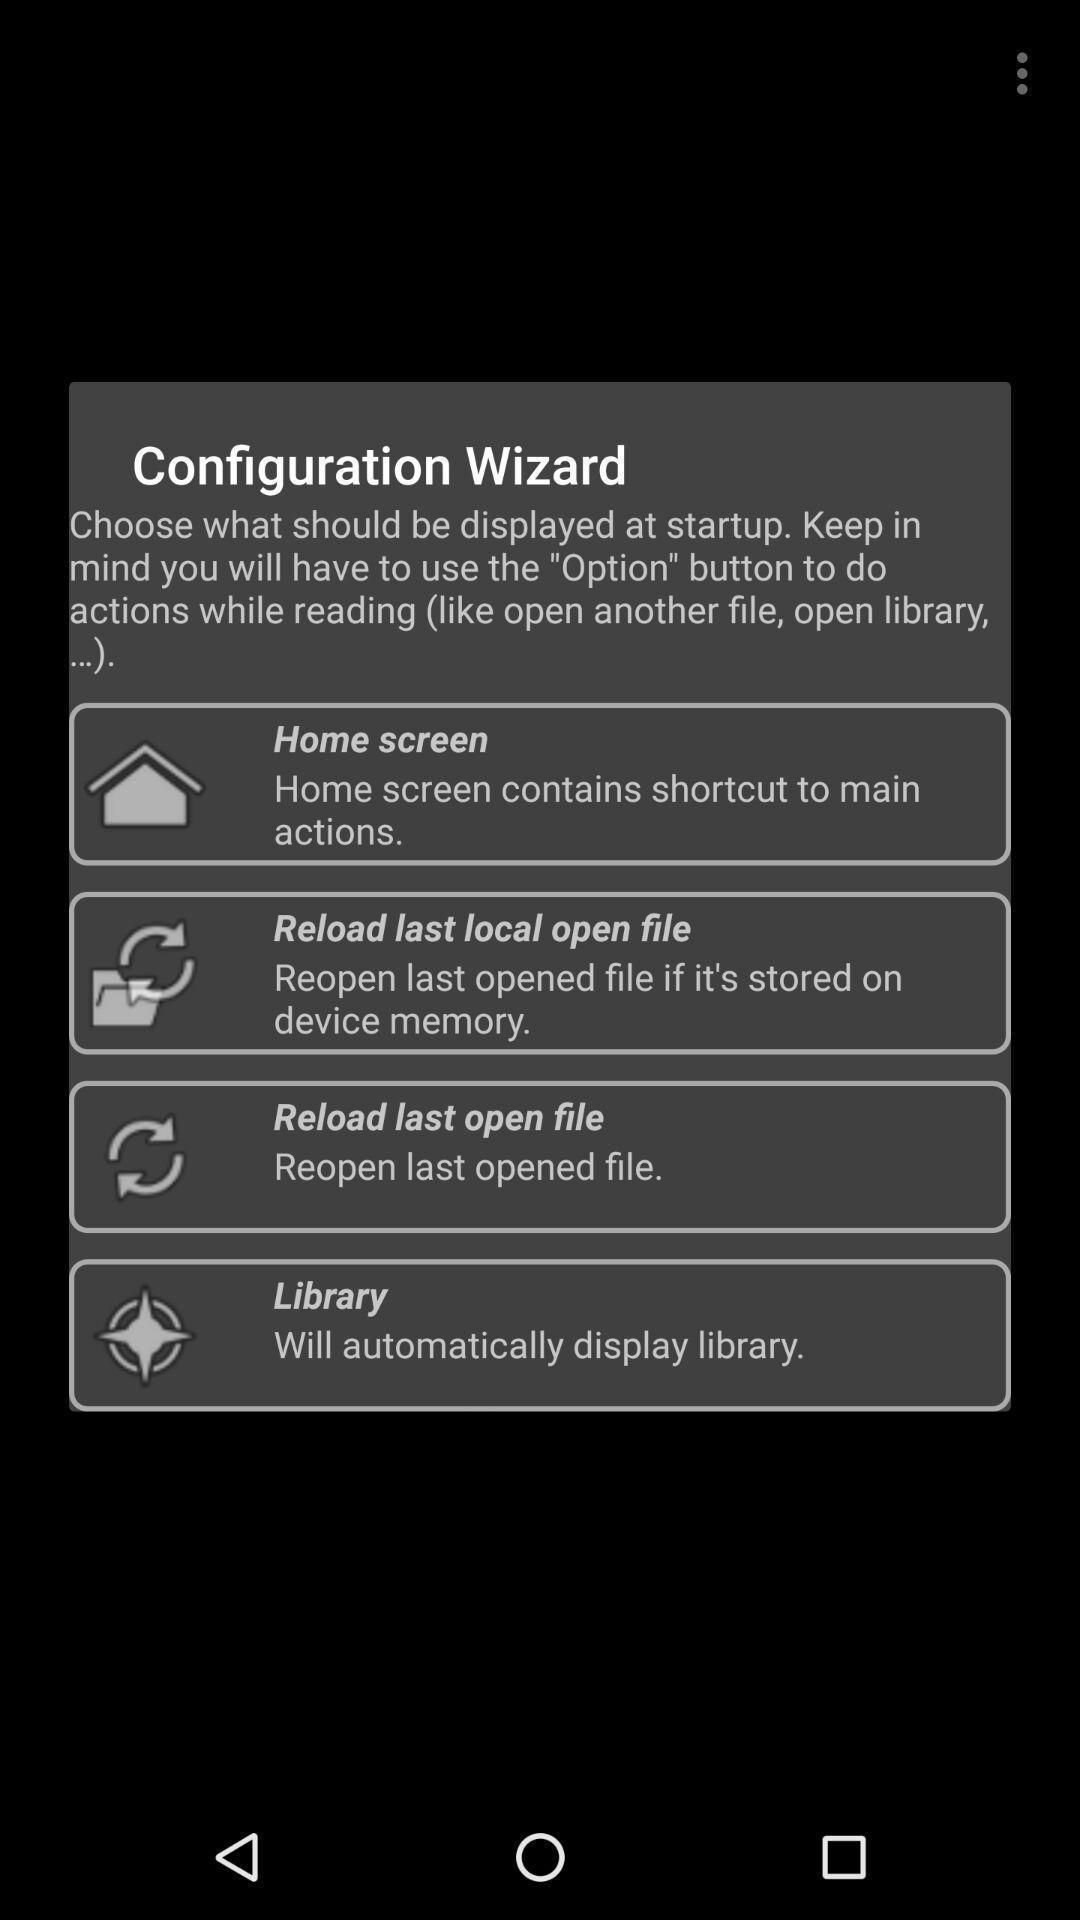Explain what's happening in this screen capture. Popup showing information about configuration. 